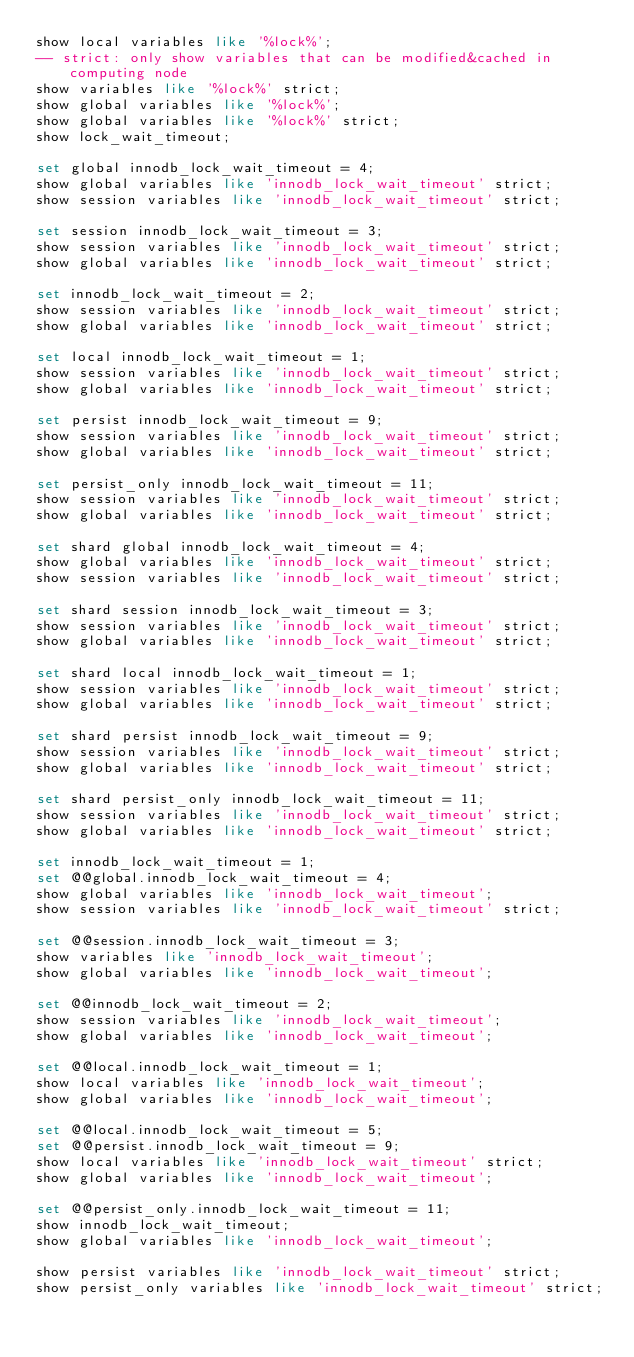Convert code to text. <code><loc_0><loc_0><loc_500><loc_500><_SQL_>show local variables like '%lock%';
-- strict: only show variables that can be modified&cached in computing node
show variables like '%lock%' strict;
show global variables like '%lock%';
show global variables like '%lock%' strict;
show lock_wait_timeout;

set global innodb_lock_wait_timeout = 4;
show global variables like 'innodb_lock_wait_timeout' strict;
show session variables like 'innodb_lock_wait_timeout' strict;

set session innodb_lock_wait_timeout = 3;
show session variables like 'innodb_lock_wait_timeout' strict;
show global variables like 'innodb_lock_wait_timeout' strict;

set innodb_lock_wait_timeout = 2;
show session variables like 'innodb_lock_wait_timeout' strict;
show global variables like 'innodb_lock_wait_timeout' strict;

set local innodb_lock_wait_timeout = 1;
show session variables like 'innodb_lock_wait_timeout' strict;
show global variables like 'innodb_lock_wait_timeout' strict;

set persist innodb_lock_wait_timeout = 9;
show session variables like 'innodb_lock_wait_timeout' strict;
show global variables like 'innodb_lock_wait_timeout' strict;

set persist_only innodb_lock_wait_timeout = 11;
show session variables like 'innodb_lock_wait_timeout' strict;
show global variables like 'innodb_lock_wait_timeout' strict;

set shard global innodb_lock_wait_timeout = 4;
show global variables like 'innodb_lock_wait_timeout' strict;
show session variables like 'innodb_lock_wait_timeout' strict;

set shard session innodb_lock_wait_timeout = 3;
show session variables like 'innodb_lock_wait_timeout' strict;
show global variables like 'innodb_lock_wait_timeout' strict;

set shard local innodb_lock_wait_timeout = 1;
show session variables like 'innodb_lock_wait_timeout' strict;
show global variables like 'innodb_lock_wait_timeout' strict;

set shard persist innodb_lock_wait_timeout = 9;
show session variables like 'innodb_lock_wait_timeout' strict;
show global variables like 'innodb_lock_wait_timeout' strict;

set shard persist_only innodb_lock_wait_timeout = 11;
show session variables like 'innodb_lock_wait_timeout' strict;
show global variables like 'innodb_lock_wait_timeout' strict;

set innodb_lock_wait_timeout = 1;
set @@global.innodb_lock_wait_timeout = 4;
show global variables like 'innodb_lock_wait_timeout';
show session variables like 'innodb_lock_wait_timeout' strict;

set @@session.innodb_lock_wait_timeout = 3;
show variables like 'innodb_lock_wait_timeout';
show global variables like 'innodb_lock_wait_timeout';

set @@innodb_lock_wait_timeout = 2;
show session variables like 'innodb_lock_wait_timeout';
show global variables like 'innodb_lock_wait_timeout';

set @@local.innodb_lock_wait_timeout = 1;
show local variables like 'innodb_lock_wait_timeout';
show global variables like 'innodb_lock_wait_timeout';

set @@local.innodb_lock_wait_timeout = 5;
set @@persist.innodb_lock_wait_timeout = 9;
show local variables like 'innodb_lock_wait_timeout' strict;
show global variables like 'innodb_lock_wait_timeout';

set @@persist_only.innodb_lock_wait_timeout = 11;
show innodb_lock_wait_timeout;
show global variables like 'innodb_lock_wait_timeout';

show persist variables like 'innodb_lock_wait_timeout' strict;
show persist_only variables like 'innodb_lock_wait_timeout' strict;
</code> 